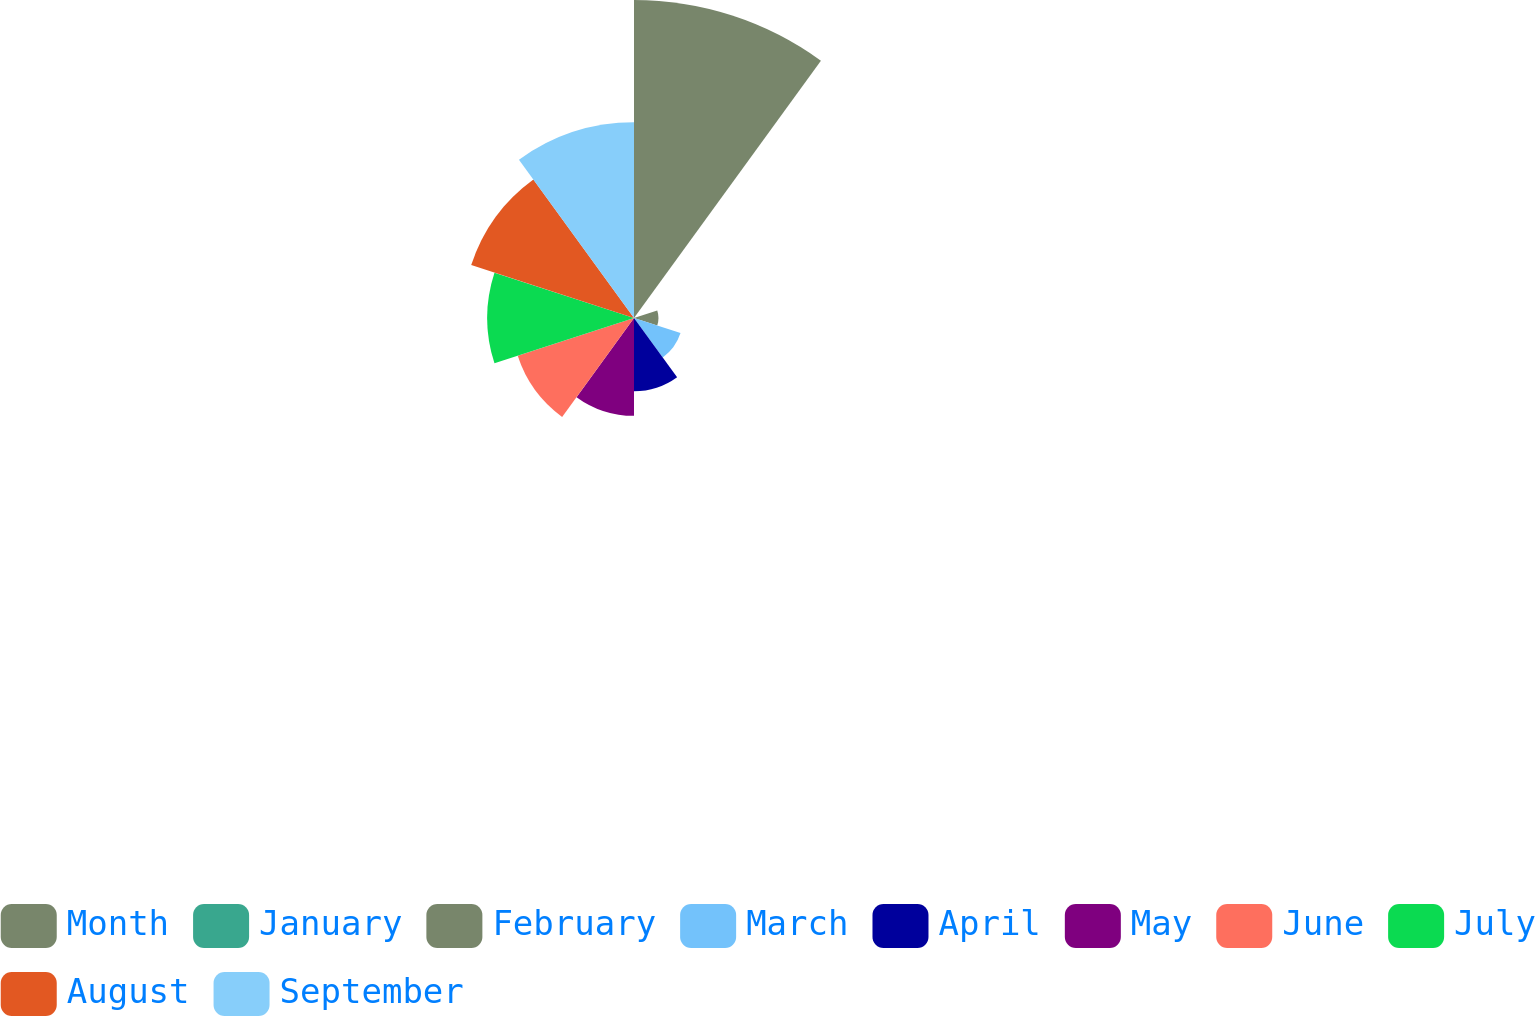Convert chart to OTSL. <chart><loc_0><loc_0><loc_500><loc_500><pie_chart><fcel>Month<fcel>January<fcel>February<fcel>March<fcel>April<fcel>May<fcel>June<fcel>July<fcel>August<fcel>September<nl><fcel>26.53%<fcel>0.0%<fcel>2.04%<fcel>4.08%<fcel>6.12%<fcel>8.16%<fcel>10.2%<fcel>12.24%<fcel>14.28%<fcel>16.33%<nl></chart> 